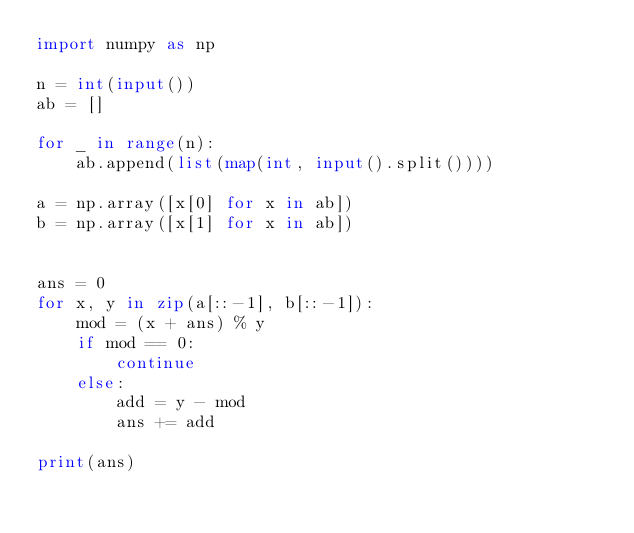<code> <loc_0><loc_0><loc_500><loc_500><_Python_>import numpy as np

n = int(input())
ab = []

for _ in range(n):
    ab.append(list(map(int, input().split())))

a = np.array([x[0] for x in ab])
b = np.array([x[1] for x in ab])


ans = 0
for x, y in zip(a[::-1], b[::-1]):
    mod = (x + ans) % y
    if mod == 0:
        continue
    else:
        add = y - mod
        ans += add

print(ans)</code> 